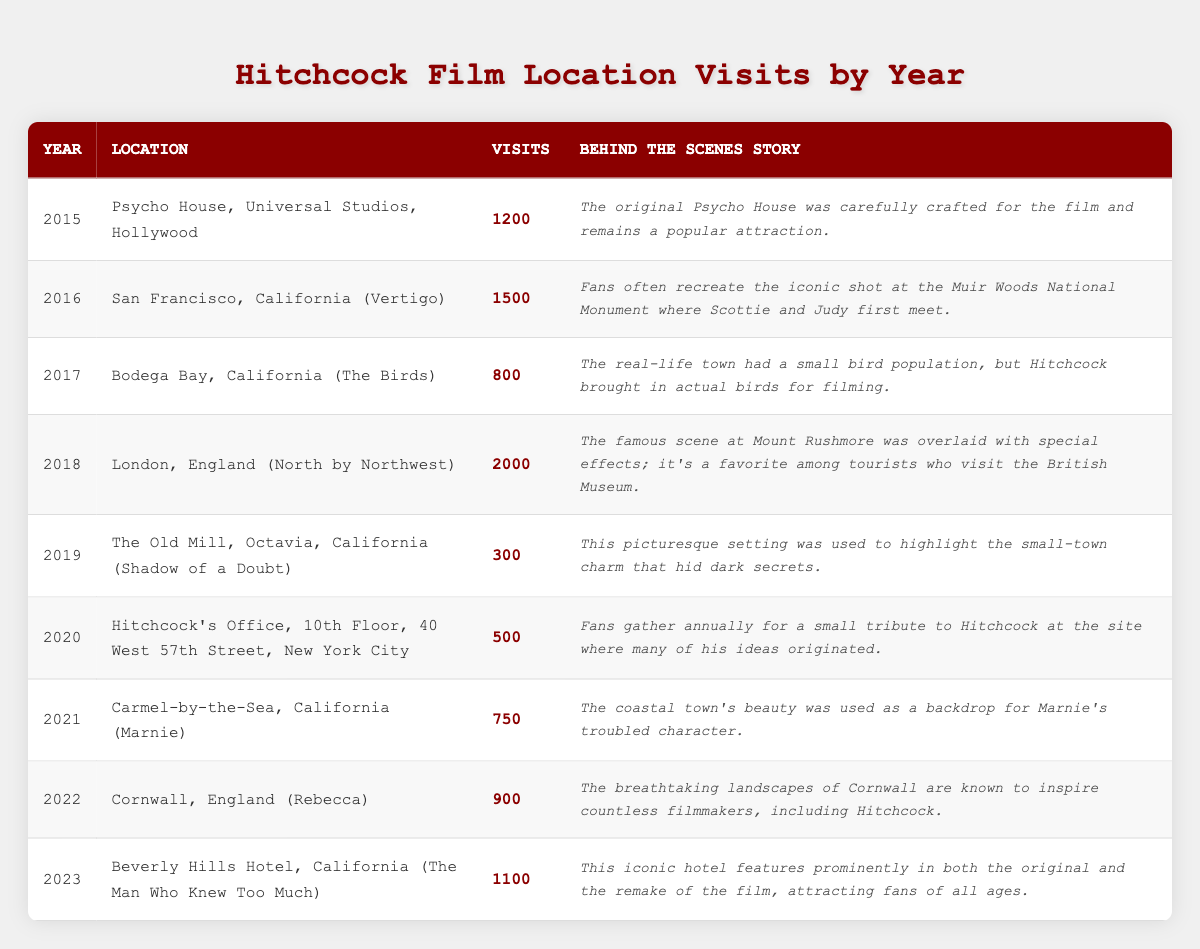What is the most visited Hitchcock film location from the table? The table lists visits by year for different locations. The highest visits are for London, England (North by Northwest) with 2000 visits in 2018.
Answer: London, England (North by Northwest) How many visits did the Psycho House receive in 2015? The table shows that the Psycho House, Universal Studios, Hollywood recorded 1200 visits in 2015.
Answer: 1200 What location had the least number of visits? Examining the visits column reveals that The Old Mill, Octavia, California (Shadow of a Doubt) had the least with 300 visits in 2019.
Answer: The Old Mill, Octavia, California (Shadow of a Doubt) What is the total number of visits across all years listed? Adding the visits from each year: 1200 + 1500 + 800 + 2000 + 300 + 500 + 750 + 900 + 1100 gives a total of 8050 visits.
Answer: 8050 In which year did the location in Carmel-by-the-Sea have its visits? The table indicates that Carmel-by-the-Sea, California (Marnie) had 750 visits in 2021.
Answer: 2021 What location had more visits: Hitchcock's Office or Bodega Bay? Hitchcock's Office had 500 visits in 2020, while Bodega Bay had 800 visits in 2017, so Bodega Bay had more visits.
Answer: Bodega Bay Was 2022 a year when visits exceeded 900? The table shows that only Cornwall, England (Rebecca) had 900 visits in 2022, which means it did not exceed 900 visits.
Answer: No What is the average number of visits for locations from 2015 to 2017? The visits for 2015, 2016, and 2017 are 1200, 1500, and 800 respectively. Adding these gives 3500, and averaging over 3 years gives 3500/3 = 1166.67.
Answer: 1166.67 Did the visit numbers increase every year? By comparing the visits year by year in the table, it's clear that they did not increase every year; they fluctuated. Specifically, 2019 and 2020 saw a decrease in visits from 2000 and 1500 respectively.
Answer: No Which film location had the highest increase in visits from 2019 to 2020? The visits for The Old Mill (2019) were 300, and for Hitchcock's Office (2020) it was 500. The increase is 500 - 300 = 200, which is the highest increase for this pair of years compared to others.
Answer: Hitchcock's Office 